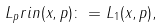<formula> <loc_0><loc_0><loc_500><loc_500>L _ { p } r i n ( x , p ) \colon = L _ { 1 } ( x , p ) ,</formula> 